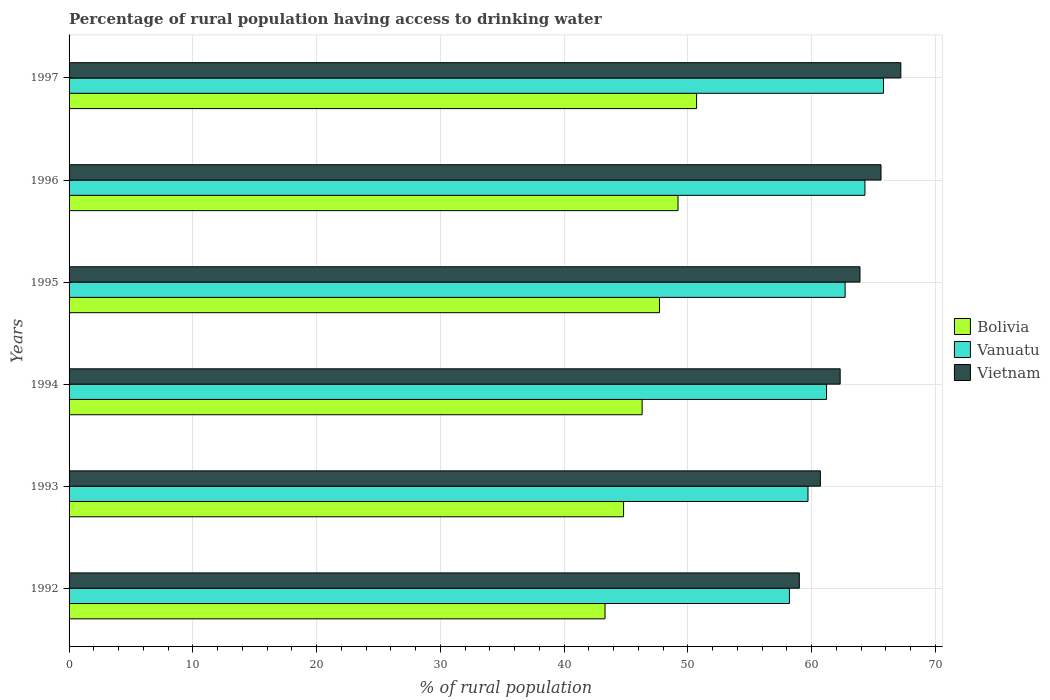How many different coloured bars are there?
Your response must be concise. 3. What is the label of the 4th group of bars from the top?
Offer a terse response. 1994. What is the percentage of rural population having access to drinking water in Vietnam in 1995?
Offer a very short reply. 63.9. Across all years, what is the maximum percentage of rural population having access to drinking water in Vanuatu?
Ensure brevity in your answer.  65.8. Across all years, what is the minimum percentage of rural population having access to drinking water in Vanuatu?
Provide a short and direct response. 58.2. In which year was the percentage of rural population having access to drinking water in Vanuatu maximum?
Your answer should be very brief. 1997. In which year was the percentage of rural population having access to drinking water in Vietnam minimum?
Ensure brevity in your answer.  1992. What is the total percentage of rural population having access to drinking water in Vanuatu in the graph?
Offer a very short reply. 371.9. What is the difference between the percentage of rural population having access to drinking water in Vanuatu in 1994 and that in 1996?
Provide a succinct answer. -3.1. What is the difference between the percentage of rural population having access to drinking water in Bolivia in 1994 and the percentage of rural population having access to drinking water in Vanuatu in 1996?
Offer a very short reply. -18. What is the average percentage of rural population having access to drinking water in Vanuatu per year?
Provide a short and direct response. 61.98. In the year 1992, what is the difference between the percentage of rural population having access to drinking water in Vanuatu and percentage of rural population having access to drinking water in Vietnam?
Provide a short and direct response. -0.8. In how many years, is the percentage of rural population having access to drinking water in Vanuatu greater than 24 %?
Make the answer very short. 6. What is the ratio of the percentage of rural population having access to drinking water in Vanuatu in 1993 to that in 1994?
Offer a very short reply. 0.98. Is the difference between the percentage of rural population having access to drinking water in Vanuatu in 1992 and 1997 greater than the difference between the percentage of rural population having access to drinking water in Vietnam in 1992 and 1997?
Offer a terse response. Yes. What is the difference between the highest and the second highest percentage of rural population having access to drinking water in Vietnam?
Offer a very short reply. 1.6. What is the difference between the highest and the lowest percentage of rural population having access to drinking water in Bolivia?
Your answer should be compact. 7.4. In how many years, is the percentage of rural population having access to drinking water in Vietnam greater than the average percentage of rural population having access to drinking water in Vietnam taken over all years?
Provide a short and direct response. 3. What does the 2nd bar from the top in 1994 represents?
Ensure brevity in your answer.  Vanuatu. What does the 1st bar from the bottom in 1993 represents?
Make the answer very short. Bolivia. How many bars are there?
Provide a short and direct response. 18. Are all the bars in the graph horizontal?
Your response must be concise. Yes. What is the difference between two consecutive major ticks on the X-axis?
Provide a short and direct response. 10. Does the graph contain any zero values?
Your answer should be compact. No. Does the graph contain grids?
Provide a short and direct response. Yes. Where does the legend appear in the graph?
Provide a short and direct response. Center right. How many legend labels are there?
Your response must be concise. 3. How are the legend labels stacked?
Your response must be concise. Vertical. What is the title of the graph?
Give a very brief answer. Percentage of rural population having access to drinking water. Does "Timor-Leste" appear as one of the legend labels in the graph?
Provide a short and direct response. No. What is the label or title of the X-axis?
Your answer should be compact. % of rural population. What is the label or title of the Y-axis?
Your answer should be compact. Years. What is the % of rural population in Bolivia in 1992?
Provide a succinct answer. 43.3. What is the % of rural population of Vanuatu in 1992?
Provide a succinct answer. 58.2. What is the % of rural population of Bolivia in 1993?
Your answer should be compact. 44.8. What is the % of rural population of Vanuatu in 1993?
Offer a very short reply. 59.7. What is the % of rural population in Vietnam in 1993?
Offer a very short reply. 60.7. What is the % of rural population of Bolivia in 1994?
Make the answer very short. 46.3. What is the % of rural population in Vanuatu in 1994?
Provide a succinct answer. 61.2. What is the % of rural population in Vietnam in 1994?
Your answer should be very brief. 62.3. What is the % of rural population of Bolivia in 1995?
Ensure brevity in your answer.  47.7. What is the % of rural population in Vanuatu in 1995?
Provide a succinct answer. 62.7. What is the % of rural population of Vietnam in 1995?
Your answer should be very brief. 63.9. What is the % of rural population of Bolivia in 1996?
Ensure brevity in your answer.  49.2. What is the % of rural population in Vanuatu in 1996?
Provide a short and direct response. 64.3. What is the % of rural population of Vietnam in 1996?
Your answer should be compact. 65.6. What is the % of rural population of Bolivia in 1997?
Give a very brief answer. 50.7. What is the % of rural population in Vanuatu in 1997?
Offer a very short reply. 65.8. What is the % of rural population in Vietnam in 1997?
Your answer should be very brief. 67.2. Across all years, what is the maximum % of rural population in Bolivia?
Give a very brief answer. 50.7. Across all years, what is the maximum % of rural population of Vanuatu?
Your answer should be compact. 65.8. Across all years, what is the maximum % of rural population in Vietnam?
Your answer should be very brief. 67.2. Across all years, what is the minimum % of rural population in Bolivia?
Keep it short and to the point. 43.3. Across all years, what is the minimum % of rural population of Vanuatu?
Your answer should be very brief. 58.2. Across all years, what is the minimum % of rural population of Vietnam?
Offer a very short reply. 59. What is the total % of rural population of Bolivia in the graph?
Your answer should be compact. 282. What is the total % of rural population of Vanuatu in the graph?
Offer a very short reply. 371.9. What is the total % of rural population of Vietnam in the graph?
Offer a terse response. 378.7. What is the difference between the % of rural population of Vanuatu in 1992 and that in 1994?
Make the answer very short. -3. What is the difference between the % of rural population in Vietnam in 1992 and that in 1994?
Make the answer very short. -3.3. What is the difference between the % of rural population in Bolivia in 1992 and that in 1995?
Offer a very short reply. -4.4. What is the difference between the % of rural population of Vanuatu in 1992 and that in 1995?
Provide a succinct answer. -4.5. What is the difference between the % of rural population in Vietnam in 1992 and that in 1995?
Provide a succinct answer. -4.9. What is the difference between the % of rural population in Vanuatu in 1992 and that in 1997?
Make the answer very short. -7.6. What is the difference between the % of rural population in Bolivia in 1993 and that in 1994?
Make the answer very short. -1.5. What is the difference between the % of rural population in Vietnam in 1993 and that in 1995?
Your answer should be very brief. -3.2. What is the difference between the % of rural population in Vanuatu in 1994 and that in 1995?
Provide a short and direct response. -1.5. What is the difference between the % of rural population of Vietnam in 1994 and that in 1995?
Provide a succinct answer. -1.6. What is the difference between the % of rural population in Vanuatu in 1994 and that in 1996?
Provide a succinct answer. -3.1. What is the difference between the % of rural population in Bolivia in 1994 and that in 1997?
Provide a short and direct response. -4.4. What is the difference between the % of rural population of Vanuatu in 1994 and that in 1997?
Provide a succinct answer. -4.6. What is the difference between the % of rural population of Vietnam in 1994 and that in 1997?
Your answer should be compact. -4.9. What is the difference between the % of rural population in Vietnam in 1995 and that in 1996?
Offer a terse response. -1.7. What is the difference between the % of rural population of Bolivia in 1996 and that in 1997?
Your response must be concise. -1.5. What is the difference between the % of rural population of Vanuatu in 1996 and that in 1997?
Offer a very short reply. -1.5. What is the difference between the % of rural population of Vietnam in 1996 and that in 1997?
Provide a succinct answer. -1.6. What is the difference between the % of rural population of Bolivia in 1992 and the % of rural population of Vanuatu in 1993?
Your response must be concise. -16.4. What is the difference between the % of rural population in Bolivia in 1992 and the % of rural population in Vietnam in 1993?
Provide a succinct answer. -17.4. What is the difference between the % of rural population of Bolivia in 1992 and the % of rural population of Vanuatu in 1994?
Provide a short and direct response. -17.9. What is the difference between the % of rural population of Bolivia in 1992 and the % of rural population of Vanuatu in 1995?
Give a very brief answer. -19.4. What is the difference between the % of rural population of Bolivia in 1992 and the % of rural population of Vietnam in 1995?
Provide a short and direct response. -20.6. What is the difference between the % of rural population in Vanuatu in 1992 and the % of rural population in Vietnam in 1995?
Offer a very short reply. -5.7. What is the difference between the % of rural population in Bolivia in 1992 and the % of rural population in Vietnam in 1996?
Your answer should be compact. -22.3. What is the difference between the % of rural population in Vanuatu in 1992 and the % of rural population in Vietnam in 1996?
Give a very brief answer. -7.4. What is the difference between the % of rural population of Bolivia in 1992 and the % of rural population of Vanuatu in 1997?
Your answer should be very brief. -22.5. What is the difference between the % of rural population in Bolivia in 1992 and the % of rural population in Vietnam in 1997?
Offer a terse response. -23.9. What is the difference between the % of rural population of Bolivia in 1993 and the % of rural population of Vanuatu in 1994?
Offer a very short reply. -16.4. What is the difference between the % of rural population of Bolivia in 1993 and the % of rural population of Vietnam in 1994?
Offer a terse response. -17.5. What is the difference between the % of rural population of Vanuatu in 1993 and the % of rural population of Vietnam in 1994?
Your answer should be compact. -2.6. What is the difference between the % of rural population in Bolivia in 1993 and the % of rural population in Vanuatu in 1995?
Provide a succinct answer. -17.9. What is the difference between the % of rural population of Bolivia in 1993 and the % of rural population of Vietnam in 1995?
Ensure brevity in your answer.  -19.1. What is the difference between the % of rural population of Bolivia in 1993 and the % of rural population of Vanuatu in 1996?
Your response must be concise. -19.5. What is the difference between the % of rural population of Bolivia in 1993 and the % of rural population of Vietnam in 1996?
Provide a succinct answer. -20.8. What is the difference between the % of rural population of Bolivia in 1993 and the % of rural population of Vietnam in 1997?
Provide a succinct answer. -22.4. What is the difference between the % of rural population of Bolivia in 1994 and the % of rural population of Vanuatu in 1995?
Offer a very short reply. -16.4. What is the difference between the % of rural population in Bolivia in 1994 and the % of rural population in Vietnam in 1995?
Provide a succinct answer. -17.6. What is the difference between the % of rural population in Vanuatu in 1994 and the % of rural population in Vietnam in 1995?
Your response must be concise. -2.7. What is the difference between the % of rural population in Bolivia in 1994 and the % of rural population in Vanuatu in 1996?
Keep it short and to the point. -18. What is the difference between the % of rural population in Bolivia in 1994 and the % of rural population in Vietnam in 1996?
Offer a terse response. -19.3. What is the difference between the % of rural population of Vanuatu in 1994 and the % of rural population of Vietnam in 1996?
Make the answer very short. -4.4. What is the difference between the % of rural population in Bolivia in 1994 and the % of rural population in Vanuatu in 1997?
Keep it short and to the point. -19.5. What is the difference between the % of rural population in Bolivia in 1994 and the % of rural population in Vietnam in 1997?
Give a very brief answer. -20.9. What is the difference between the % of rural population of Vanuatu in 1994 and the % of rural population of Vietnam in 1997?
Ensure brevity in your answer.  -6. What is the difference between the % of rural population of Bolivia in 1995 and the % of rural population of Vanuatu in 1996?
Your answer should be very brief. -16.6. What is the difference between the % of rural population in Bolivia in 1995 and the % of rural population in Vietnam in 1996?
Your answer should be very brief. -17.9. What is the difference between the % of rural population of Bolivia in 1995 and the % of rural population of Vanuatu in 1997?
Your answer should be compact. -18.1. What is the difference between the % of rural population in Bolivia in 1995 and the % of rural population in Vietnam in 1997?
Your answer should be very brief. -19.5. What is the difference between the % of rural population in Vanuatu in 1995 and the % of rural population in Vietnam in 1997?
Ensure brevity in your answer.  -4.5. What is the difference between the % of rural population of Bolivia in 1996 and the % of rural population of Vanuatu in 1997?
Provide a succinct answer. -16.6. What is the difference between the % of rural population of Bolivia in 1996 and the % of rural population of Vietnam in 1997?
Offer a terse response. -18. What is the difference between the % of rural population in Vanuatu in 1996 and the % of rural population in Vietnam in 1997?
Make the answer very short. -2.9. What is the average % of rural population in Vanuatu per year?
Provide a short and direct response. 61.98. What is the average % of rural population in Vietnam per year?
Make the answer very short. 63.12. In the year 1992, what is the difference between the % of rural population of Bolivia and % of rural population of Vanuatu?
Your answer should be compact. -14.9. In the year 1992, what is the difference between the % of rural population in Bolivia and % of rural population in Vietnam?
Your answer should be compact. -15.7. In the year 1992, what is the difference between the % of rural population in Vanuatu and % of rural population in Vietnam?
Provide a short and direct response. -0.8. In the year 1993, what is the difference between the % of rural population of Bolivia and % of rural population of Vanuatu?
Give a very brief answer. -14.9. In the year 1993, what is the difference between the % of rural population of Bolivia and % of rural population of Vietnam?
Give a very brief answer. -15.9. In the year 1993, what is the difference between the % of rural population of Vanuatu and % of rural population of Vietnam?
Provide a short and direct response. -1. In the year 1994, what is the difference between the % of rural population of Bolivia and % of rural population of Vanuatu?
Ensure brevity in your answer.  -14.9. In the year 1994, what is the difference between the % of rural population of Vanuatu and % of rural population of Vietnam?
Ensure brevity in your answer.  -1.1. In the year 1995, what is the difference between the % of rural population of Bolivia and % of rural population of Vietnam?
Give a very brief answer. -16.2. In the year 1995, what is the difference between the % of rural population of Vanuatu and % of rural population of Vietnam?
Make the answer very short. -1.2. In the year 1996, what is the difference between the % of rural population of Bolivia and % of rural population of Vanuatu?
Offer a very short reply. -15.1. In the year 1996, what is the difference between the % of rural population of Bolivia and % of rural population of Vietnam?
Offer a very short reply. -16.4. In the year 1997, what is the difference between the % of rural population of Bolivia and % of rural population of Vanuatu?
Ensure brevity in your answer.  -15.1. In the year 1997, what is the difference between the % of rural population in Bolivia and % of rural population in Vietnam?
Provide a short and direct response. -16.5. What is the ratio of the % of rural population in Bolivia in 1992 to that in 1993?
Your response must be concise. 0.97. What is the ratio of the % of rural population of Vanuatu in 1992 to that in 1993?
Make the answer very short. 0.97. What is the ratio of the % of rural population in Vietnam in 1992 to that in 1993?
Offer a terse response. 0.97. What is the ratio of the % of rural population in Bolivia in 1992 to that in 1994?
Provide a succinct answer. 0.94. What is the ratio of the % of rural population in Vanuatu in 1992 to that in 1994?
Offer a terse response. 0.95. What is the ratio of the % of rural population in Vietnam in 1992 to that in 1994?
Your answer should be very brief. 0.95. What is the ratio of the % of rural population of Bolivia in 1992 to that in 1995?
Make the answer very short. 0.91. What is the ratio of the % of rural population of Vanuatu in 1992 to that in 1995?
Make the answer very short. 0.93. What is the ratio of the % of rural population of Vietnam in 1992 to that in 1995?
Your response must be concise. 0.92. What is the ratio of the % of rural population of Bolivia in 1992 to that in 1996?
Your response must be concise. 0.88. What is the ratio of the % of rural population of Vanuatu in 1992 to that in 1996?
Provide a short and direct response. 0.91. What is the ratio of the % of rural population of Vietnam in 1992 to that in 1996?
Make the answer very short. 0.9. What is the ratio of the % of rural population of Bolivia in 1992 to that in 1997?
Your answer should be very brief. 0.85. What is the ratio of the % of rural population of Vanuatu in 1992 to that in 1997?
Offer a very short reply. 0.88. What is the ratio of the % of rural population in Vietnam in 1992 to that in 1997?
Make the answer very short. 0.88. What is the ratio of the % of rural population of Bolivia in 1993 to that in 1994?
Ensure brevity in your answer.  0.97. What is the ratio of the % of rural population in Vanuatu in 1993 to that in 1994?
Provide a short and direct response. 0.98. What is the ratio of the % of rural population of Vietnam in 1993 to that in 1994?
Keep it short and to the point. 0.97. What is the ratio of the % of rural population in Bolivia in 1993 to that in 1995?
Provide a short and direct response. 0.94. What is the ratio of the % of rural population in Vanuatu in 1993 to that in 1995?
Make the answer very short. 0.95. What is the ratio of the % of rural population in Vietnam in 1993 to that in 1995?
Keep it short and to the point. 0.95. What is the ratio of the % of rural population in Bolivia in 1993 to that in 1996?
Ensure brevity in your answer.  0.91. What is the ratio of the % of rural population of Vanuatu in 1993 to that in 1996?
Your response must be concise. 0.93. What is the ratio of the % of rural population of Vietnam in 1993 to that in 1996?
Your answer should be very brief. 0.93. What is the ratio of the % of rural population in Bolivia in 1993 to that in 1997?
Give a very brief answer. 0.88. What is the ratio of the % of rural population of Vanuatu in 1993 to that in 1997?
Keep it short and to the point. 0.91. What is the ratio of the % of rural population of Vietnam in 1993 to that in 1997?
Offer a terse response. 0.9. What is the ratio of the % of rural population of Bolivia in 1994 to that in 1995?
Offer a very short reply. 0.97. What is the ratio of the % of rural population in Vanuatu in 1994 to that in 1995?
Provide a succinct answer. 0.98. What is the ratio of the % of rural population in Vietnam in 1994 to that in 1995?
Keep it short and to the point. 0.97. What is the ratio of the % of rural population in Bolivia in 1994 to that in 1996?
Offer a terse response. 0.94. What is the ratio of the % of rural population in Vanuatu in 1994 to that in 1996?
Your answer should be compact. 0.95. What is the ratio of the % of rural population of Vietnam in 1994 to that in 1996?
Provide a short and direct response. 0.95. What is the ratio of the % of rural population of Bolivia in 1994 to that in 1997?
Your response must be concise. 0.91. What is the ratio of the % of rural population in Vanuatu in 1994 to that in 1997?
Offer a terse response. 0.93. What is the ratio of the % of rural population in Vietnam in 1994 to that in 1997?
Keep it short and to the point. 0.93. What is the ratio of the % of rural population of Bolivia in 1995 to that in 1996?
Your answer should be compact. 0.97. What is the ratio of the % of rural population in Vanuatu in 1995 to that in 1996?
Keep it short and to the point. 0.98. What is the ratio of the % of rural population in Vietnam in 1995 to that in 1996?
Give a very brief answer. 0.97. What is the ratio of the % of rural population of Bolivia in 1995 to that in 1997?
Ensure brevity in your answer.  0.94. What is the ratio of the % of rural population in Vanuatu in 1995 to that in 1997?
Offer a terse response. 0.95. What is the ratio of the % of rural population of Vietnam in 1995 to that in 1997?
Provide a succinct answer. 0.95. What is the ratio of the % of rural population in Bolivia in 1996 to that in 1997?
Your answer should be very brief. 0.97. What is the ratio of the % of rural population in Vanuatu in 1996 to that in 1997?
Your response must be concise. 0.98. What is the ratio of the % of rural population of Vietnam in 1996 to that in 1997?
Provide a short and direct response. 0.98. What is the difference between the highest and the second highest % of rural population of Bolivia?
Your response must be concise. 1.5. What is the difference between the highest and the lowest % of rural population of Bolivia?
Your answer should be very brief. 7.4. What is the difference between the highest and the lowest % of rural population of Vietnam?
Your answer should be compact. 8.2. 